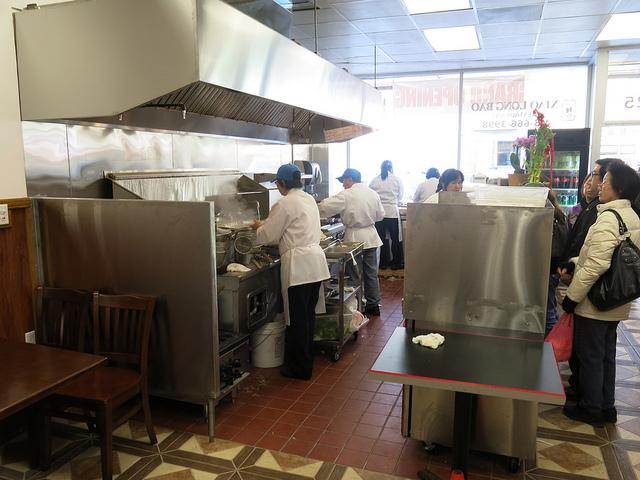Where are these people working?
Answer briefly. Restaurant. What type of equipment are the workers using?
Give a very brief answer. Kitchen. What are the people in line for?
Keep it brief. Food. Is this a family?
Give a very brief answer. No. Why are these people standing around?
Give a very brief answer. Waiting for food. What is the only number visible in the store address?
Be succinct. 5. 